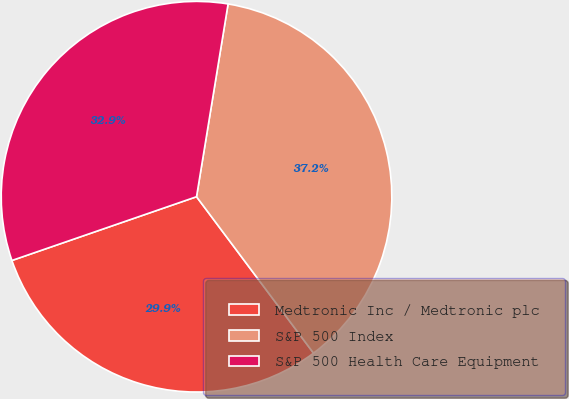Convert chart. <chart><loc_0><loc_0><loc_500><loc_500><pie_chart><fcel>Medtronic Inc / Medtronic plc<fcel>S&P 500 Index<fcel>S&P 500 Health Care Equipment<nl><fcel>29.93%<fcel>37.2%<fcel>32.88%<nl></chart> 